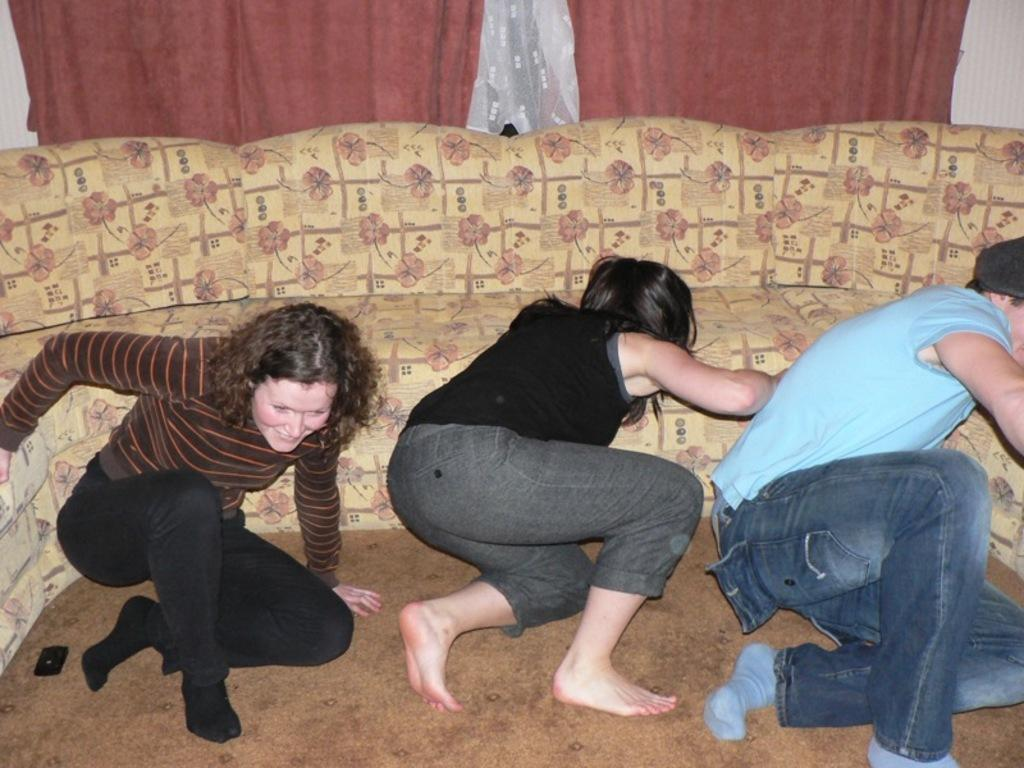How many people are in the image? There are three people in the image. Where are the people located in the image? The people are on the floor. What electronic device is visible in the image? There is a cell phone visible in the image. What type of furniture can be seen in the background of the image? There is a couch in the background of the image. What type of window treatment is present in the background of the image? There are curtains in the background of the image. What type of berry is being used as a prop in the image? There is no berry present in the image. 